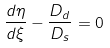Convert formula to latex. <formula><loc_0><loc_0><loc_500><loc_500>\frac { d \eta } { d \xi } - \frac { D _ { d } } { D _ { s } } = 0</formula> 